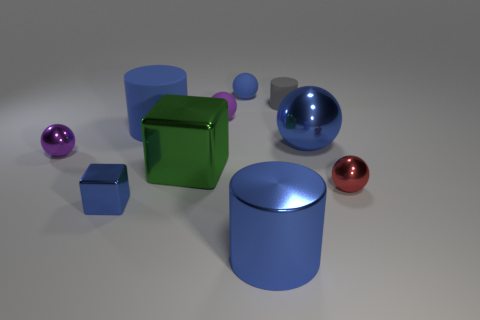Subtract all small purple rubber spheres. How many spheres are left? 4 Subtract 1 balls. How many balls are left? 4 Subtract all red balls. How many balls are left? 4 Subtract all cyan balls. Subtract all purple cylinders. How many balls are left? 5 Subtract all cubes. How many objects are left? 8 Add 2 matte balls. How many matte balls exist? 4 Subtract 0 green spheres. How many objects are left? 10 Subtract all big green matte balls. Subtract all purple metallic spheres. How many objects are left? 9 Add 6 rubber spheres. How many rubber spheres are left? 8 